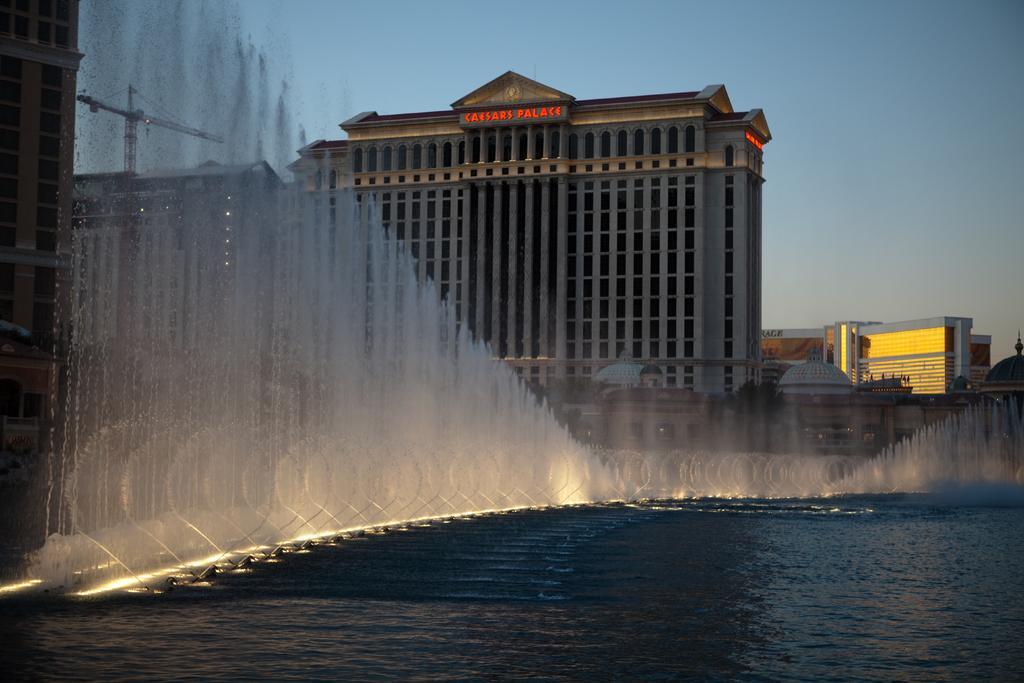Describe this image in one or two sentences. In this picture we can see the water, buildings, some objects and in the background we can see the sky. 